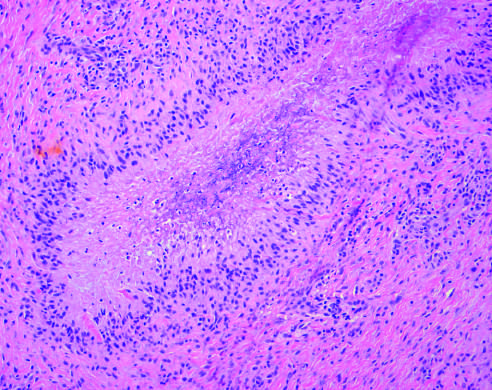s rheumatoid nodule composed of central necrosis rimmed by palisaded histiocytes?
Answer the question using a single word or phrase. Yes 